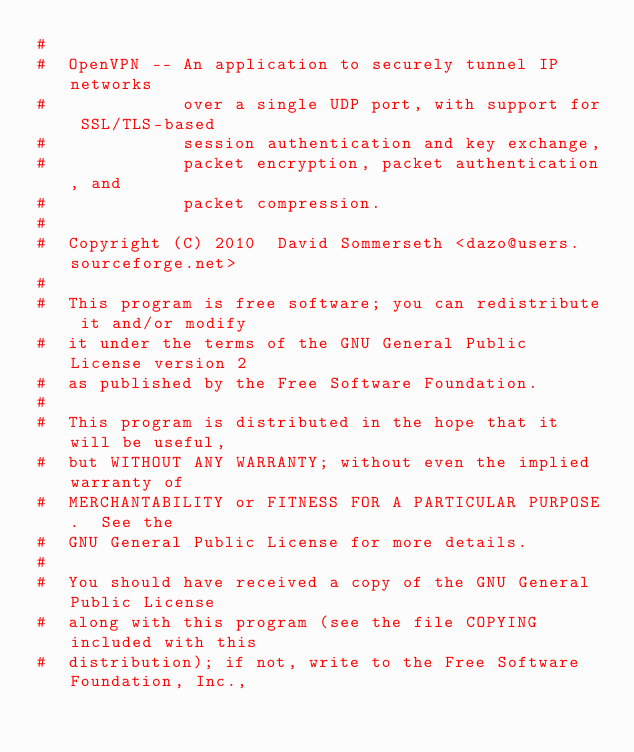Convert code to text. <code><loc_0><loc_0><loc_500><loc_500><_Awk_>#
#  OpenVPN -- An application to securely tunnel IP networks
#             over a single UDP port, with support for SSL/TLS-based
#             session authentication and key exchange,
#             packet encryption, packet authentication, and
#             packet compression.
#
#  Copyright (C) 2010  David Sommerseth <dazo@users.sourceforge.net>
#
#  This program is free software; you can redistribute it and/or modify
#  it under the terms of the GNU General Public License version 2
#  as published by the Free Software Foundation.
#
#  This program is distributed in the hope that it will be useful,
#  but WITHOUT ANY WARRANTY; without even the implied warranty of
#  MERCHANTABILITY or FITNESS FOR A PARTICULAR PURPOSE.  See the
#  GNU General Public License for more details.
#
#  You should have received a copy of the GNU General Public License
#  along with this program (see the file COPYING included with this
#  distribution); if not, write to the Free Software Foundation, Inc.,</code> 